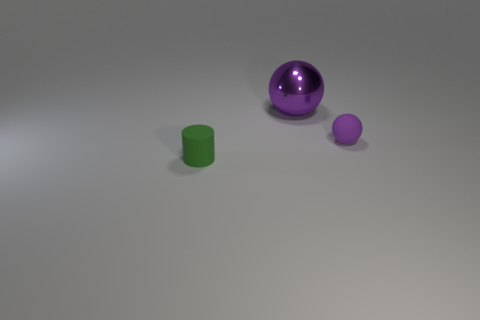There is a tiny object that is on the left side of the purple sphere that is left of the ball in front of the purple shiny thing; what shape is it?
Offer a very short reply. Cylinder. What number of other matte objects are the same shape as the big purple object?
Keep it short and to the point. 1. There is a rubber object that is to the left of the purple rubber sphere; how many tiny rubber objects are to the right of it?
Provide a succinct answer. 1. How many metal objects are either big yellow things or tiny purple things?
Offer a terse response. 0. Is there another cylinder that has the same material as the green cylinder?
Make the answer very short. No. How many objects are either matte objects that are behind the green matte cylinder or things to the left of the purple rubber object?
Provide a succinct answer. 3. There is a tiny rubber thing behind the small green cylinder; does it have the same color as the tiny matte cylinder?
Give a very brief answer. No. What number of other objects are there of the same color as the shiny ball?
Give a very brief answer. 1. What is the tiny purple sphere made of?
Offer a very short reply. Rubber. Do the rubber object behind the green rubber cylinder and the large thing have the same size?
Ensure brevity in your answer.  No. 